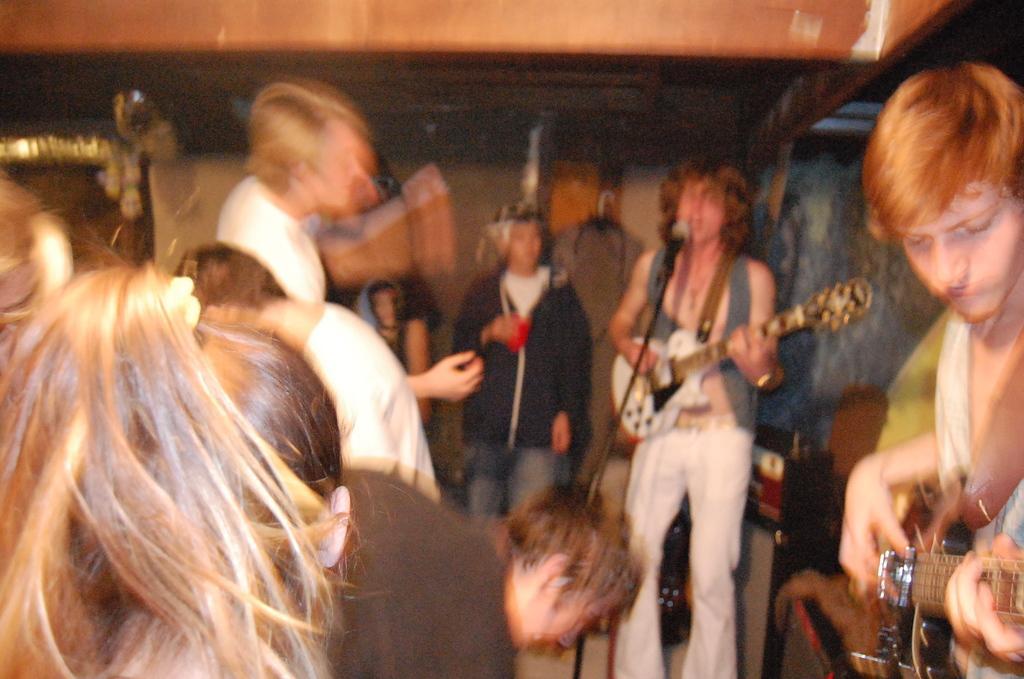Can you describe this image briefly? In the image we can see there are lot of people who are standing and men are holding guitar in their hand and people are looking at them. 